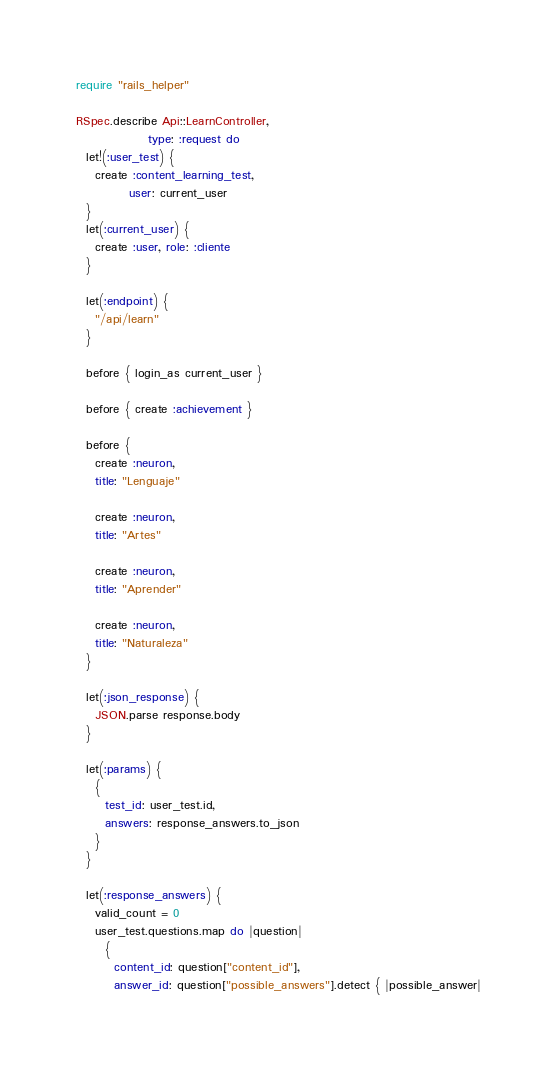Convert code to text. <code><loc_0><loc_0><loc_500><loc_500><_Ruby_>require "rails_helper"

RSpec.describe Api::LearnController,
               type: :request do
  let!(:user_test) {
    create :content_learning_test,
           user: current_user
  }
  let(:current_user) {
    create :user, role: :cliente
  }

  let(:endpoint) {
    "/api/learn"
  }

  before { login_as current_user }

  before { create :achievement }

  before {
    create :neuron,
    title: "Lenguaje"

    create :neuron,
    title: "Artes"

    create :neuron,
    title: "Aprender"

    create :neuron,
    title: "Naturaleza"
  }

  let(:json_response) {
    JSON.parse response.body
  }

  let(:params) {
    {
      test_id: user_test.id,
      answers: response_answers.to_json
    }
  }

  let(:response_answers) {
    valid_count = 0
    user_test.questions.map do |question|
      {
        content_id: question["content_id"],
        answer_id: question["possible_answers"].detect { |possible_answer|</code> 